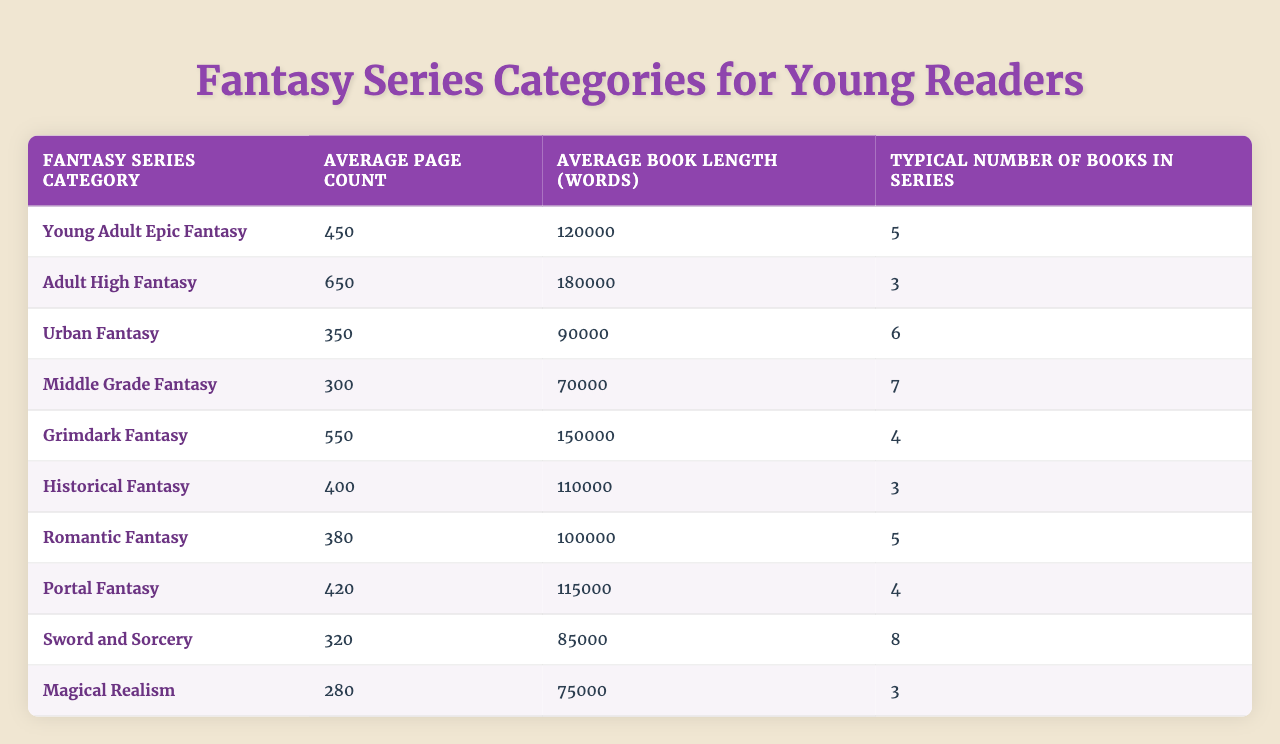What is the average page count for Young Adult Epic Fantasy? According to the table, the average page count for Young Adult Epic Fantasy is directly listed under the "Average Page Count" column, which shows 450 pages.
Answer: 450 Which fantasy series category has the highest average book length in words? The highest average book length is found by comparing the "Average Book Length (Words)" column. Adult High Fantasy shows the highest value at 180,000 words.
Answer: Adult High Fantasy What is the average page count for the sword and sorcery category? The table provides the average page count for Sword and Sorcery, which is listed as 320 pages in the "Average Page Count" column.
Answer: 320 How many books are typically in the Urban Fantasy series? The table indicates that the "Typical Number of Books in Series" for Urban Fantasy is 6, as provided in that specific row of the table.
Answer: 6 What is the difference in average page count between Adult High Fantasy and Grimdark Fantasy? The average page count for Adult High Fantasy is 650 pages, while for Grimdark Fantasy, it is 550 pages. The difference is calculated as 650 - 550 = 100 pages.
Answer: 100 Are there more average words in Romantic Fantasy compared to Historical Fantasy? Comparing the "Average Book Length (Words)," Romantic Fantasy has 100,000 words and Historical Fantasy has 110,000 words. Since 100,000 is less than 110,000, the statement is false.
Answer: No Which category has the lowest average page count? By reviewing the "Average Page Count" column, Magical Realism shows the lowest value of 280 pages compared to other categories.
Answer: Magical Realism What is the total average page count of the Middle Grade Fantasy and Young Adult Epic Fantasy categories combined? The average page count for Middle Grade Fantasy is 300 pages, and for Young Adult Epic Fantasy it's 450 pages. Adding these values together gives us 300 + 450 = 750 pages.
Answer: 750 Is the average book length for Urban Fantasy greater than that of Sword and Sorcery? Urban Fantasy has an average book length of 90,000 words, while Sword and Sorcery has 85,000 words. Since 90,000 is greater than 85,000, the statement is true.
Answer: Yes If a reader wants to read the series with the highest average book length and it has 3 books, how many total words will they read? The series with the highest average book length is Adult High Fantasy, with an average of 180,000 words per book and 3 books in the series. Multiplying these, 180,000 * 3 = 540,000 words total.
Answer: 540,000 